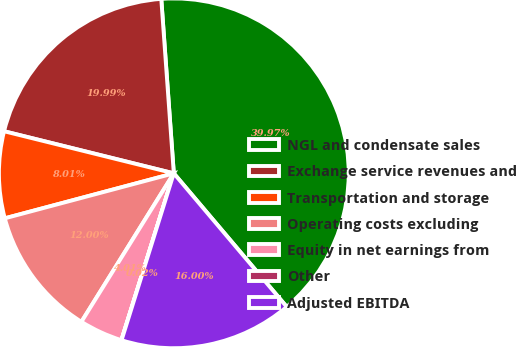<chart> <loc_0><loc_0><loc_500><loc_500><pie_chart><fcel>NGL and condensate sales<fcel>Exchange service revenues and<fcel>Transportation and storage<fcel>Operating costs excluding<fcel>Equity in net earnings from<fcel>Other<fcel>Adjusted EBITDA<nl><fcel>39.97%<fcel>19.99%<fcel>8.01%<fcel>12.0%<fcel>4.01%<fcel>0.02%<fcel>16.0%<nl></chart> 